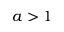<formula> <loc_0><loc_0><loc_500><loc_500>a > 1</formula> 